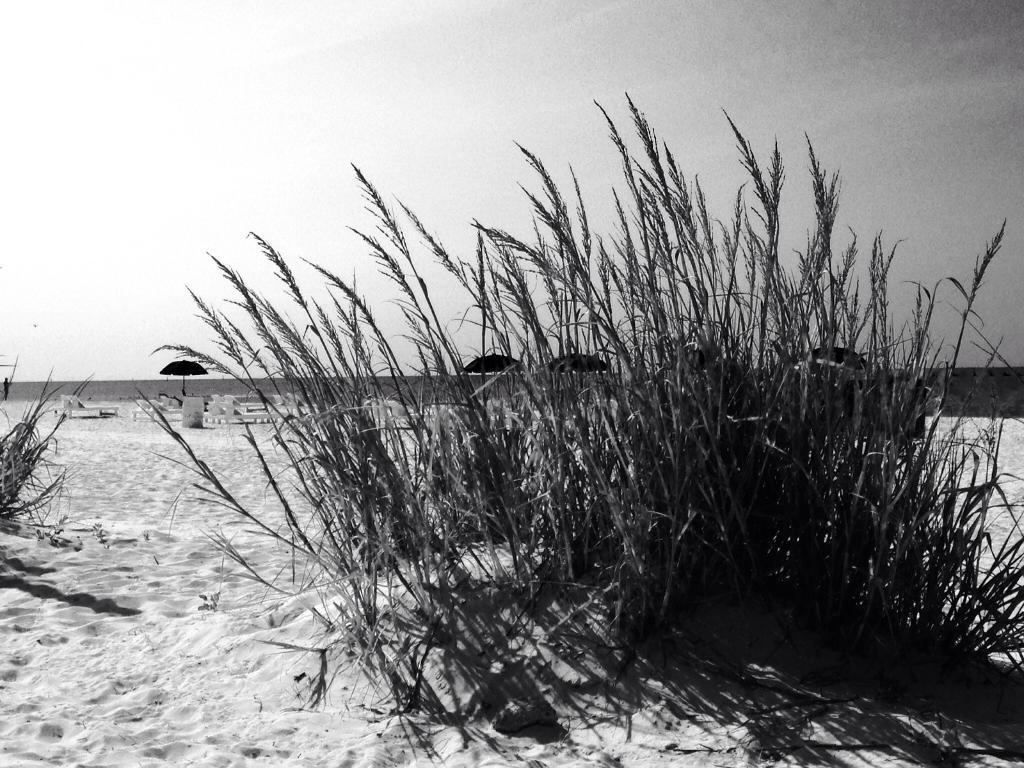What is the color scheme of the image? The image is black and white. What type of living organisms can be seen in the image? There are plants in the image. What can be seen in the background of the image? There are umbrellas, other unspecified objects, a wall, and the sky visible in the background of the image. How many cattle can be seen grazing in the image? There are no cattle present in the image. What type of war is depicted in the image? There is no war depicted in the image; it features plants, umbrellas, and other unspecified objects. Can you tell me the name of the judge in the image? There is no judge present in the image. 